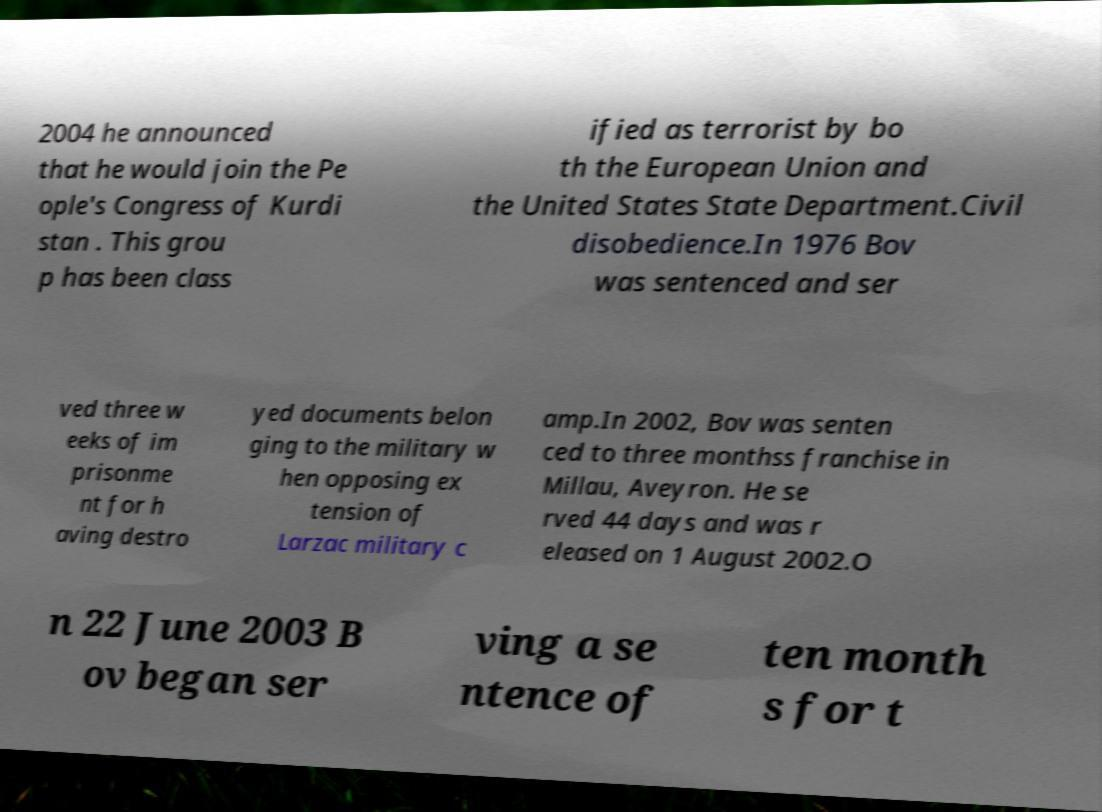There's text embedded in this image that I need extracted. Can you transcribe it verbatim? 2004 he announced that he would join the Pe ople's Congress of Kurdi stan . This grou p has been class ified as terrorist by bo th the European Union and the United States State Department.Civil disobedience.In 1976 Bov was sentenced and ser ved three w eeks of im prisonme nt for h aving destro yed documents belon ging to the military w hen opposing ex tension of Larzac military c amp.In 2002, Bov was senten ced to three monthss franchise in Millau, Aveyron. He se rved 44 days and was r eleased on 1 August 2002.O n 22 June 2003 B ov began ser ving a se ntence of ten month s for t 